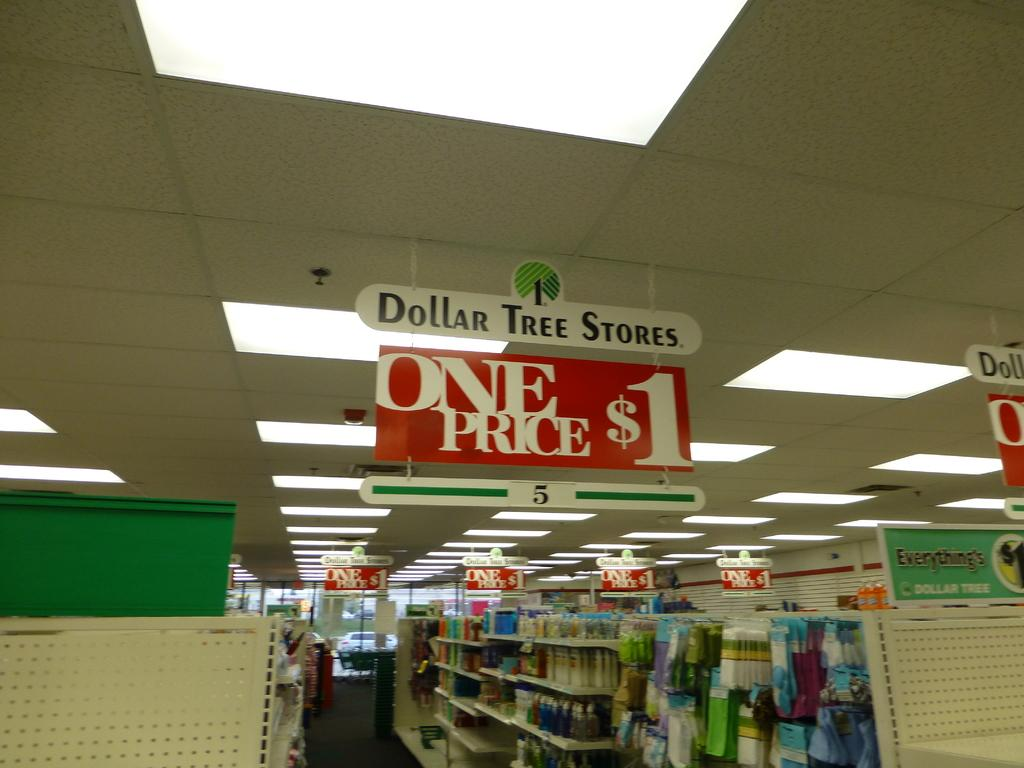Provide a one-sentence caption for the provided image. An aisle shot for a Dollar Tree, where everything is a dollar. 